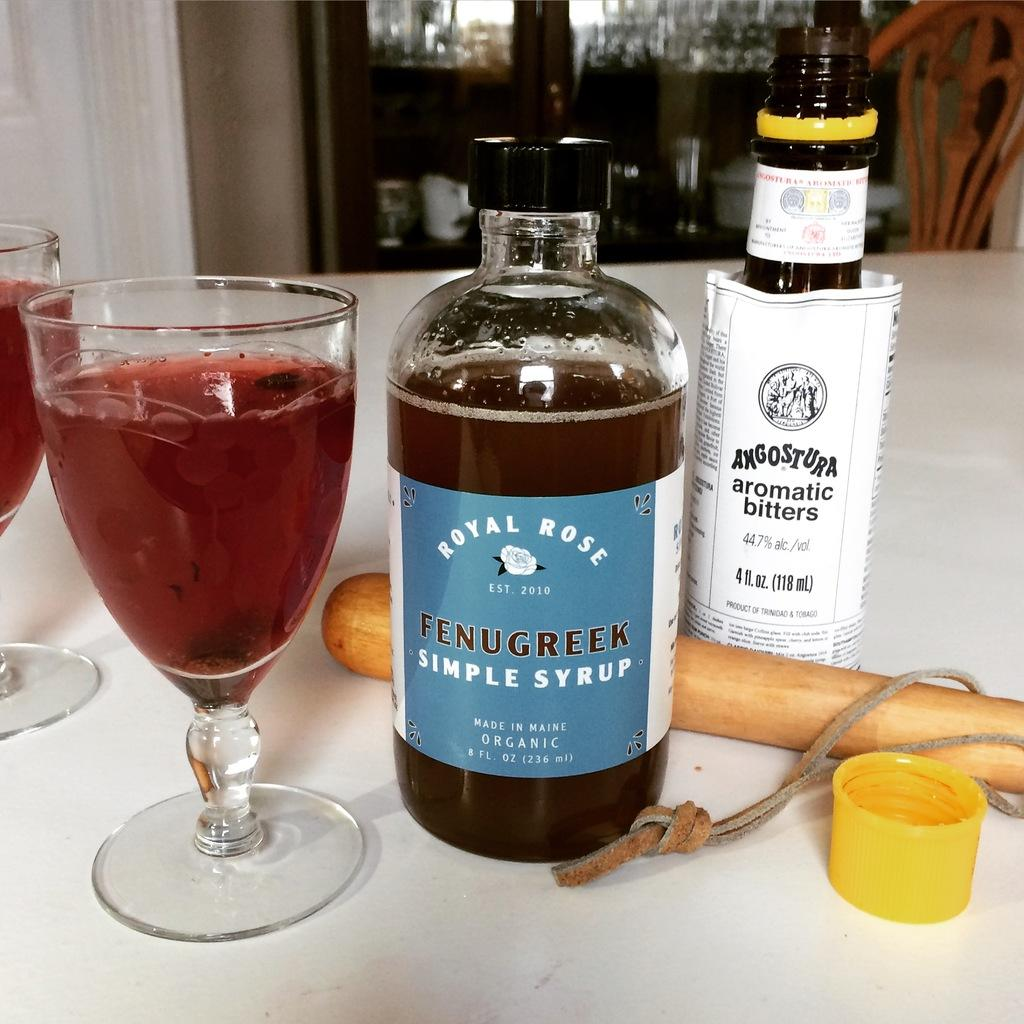<image>
Provide a brief description of the given image. Two bottles, and a glass full of Royal Rose and Aromatic bitters. 